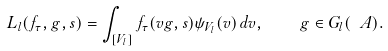Convert formula to latex. <formula><loc_0><loc_0><loc_500><loc_500>L _ { l } ( f _ { \tau } , g , s ) = \int _ { [ V _ { l } ] } f _ { \tau } ( v g , s ) \psi _ { V _ { l } } ( v ) \, d v , \quad g \in G _ { l } ( \ A ) .</formula> 